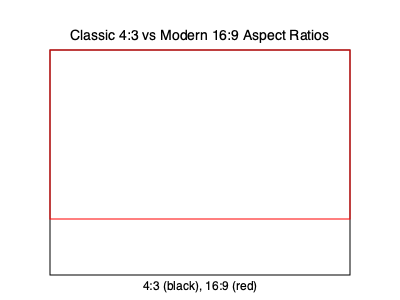In the diagram above, the black rectangle represents the classic 4:3 aspect ratio used in many films during the golden age of Hollywood, while the red rectangle shows the modern 16:9 widescreen format. Calculate the percentage of vertical space that would be lost if a classic 4:3 film were to be displayed on a 16:9 screen without cropping or adding black bars. Round your answer to the nearest whole percent. To solve this problem, let's follow these steps:

1) First, we need to understand what the aspect ratios mean:
   - 4:3 means the width is 4 units for every 3 units of height
   - 16:9 means the width is 16 units for every 9 units of height

2) Let's assume the width of both rectangles is 16 units (to match the 16:9 ratio):
   - For 16:9, the height would be 9 units
   - For 4:3, we need to calculate the height:
     If 4 units of width correspond to 3 units of height, then
     16 units of width correspond to $x$ units of height
     We can set up the proportion: $\frac{4}{3} = \frac{16}{x}$
     Cross multiply: $4x = 48$
     Solve for $x$: $x = 12$

3) So, the height of the 4:3 rectangle would be 12 units.

4) The difference in height: $12 - 9 = 3$ units

5) To calculate the percentage of vertical space lost:
   $\frac{\text{Difference in height}}{\text{Original height}} \times 100\% = \frac{3}{12} \times 100\% = 25\%$

Therefore, 25% of the vertical space would be lost when displaying a 4:3 film on a 16:9 screen without cropping or adding black bars.
Answer: 25% 